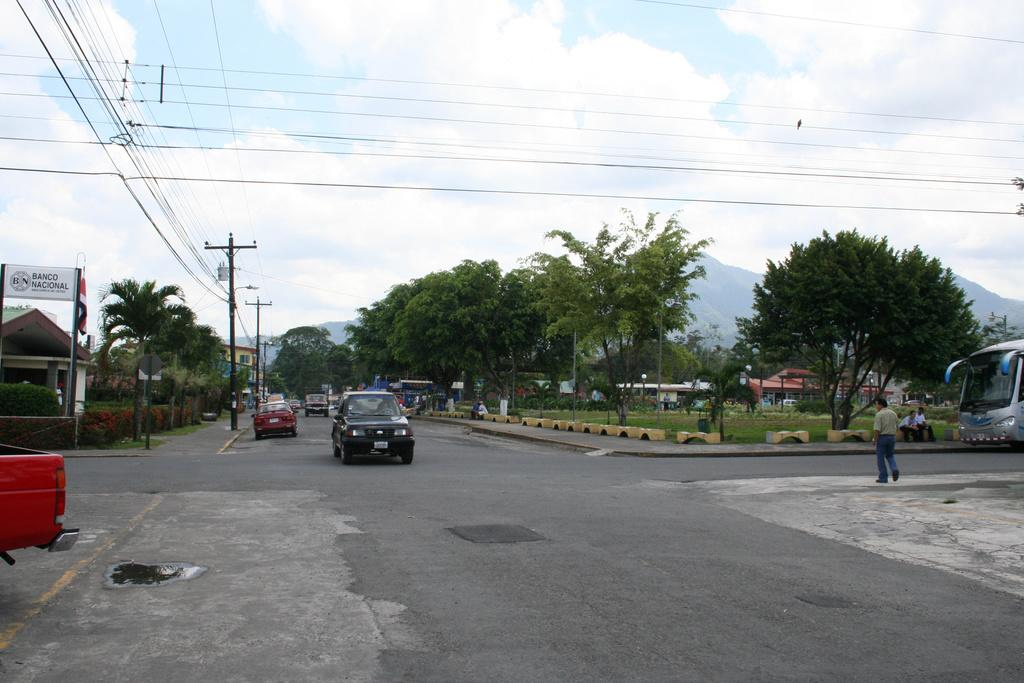What type of vehicles can be seen on the road in the image? There are cars on the road in the image. What is the man on the right side of the image doing? There is a man walking on the footpath on the right side of the image. What can be seen in the background of the image? There are trees and clouds in the sky in the background of the image. What type of tub is visible in the image? There is no tub present in the image. What kind of popcorn can be seen being prepared in the image? There is no popcorn or preparation of popcorn visible in the image. 